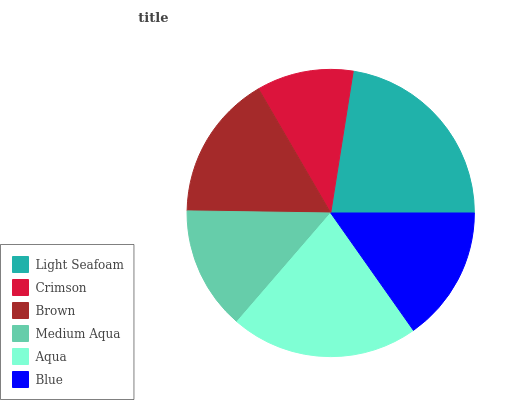Is Crimson the minimum?
Answer yes or no. Yes. Is Light Seafoam the maximum?
Answer yes or no. Yes. Is Brown the minimum?
Answer yes or no. No. Is Brown the maximum?
Answer yes or no. No. Is Brown greater than Crimson?
Answer yes or no. Yes. Is Crimson less than Brown?
Answer yes or no. Yes. Is Crimson greater than Brown?
Answer yes or no. No. Is Brown less than Crimson?
Answer yes or no. No. Is Brown the high median?
Answer yes or no. Yes. Is Blue the low median?
Answer yes or no. Yes. Is Aqua the high median?
Answer yes or no. No. Is Light Seafoam the low median?
Answer yes or no. No. 